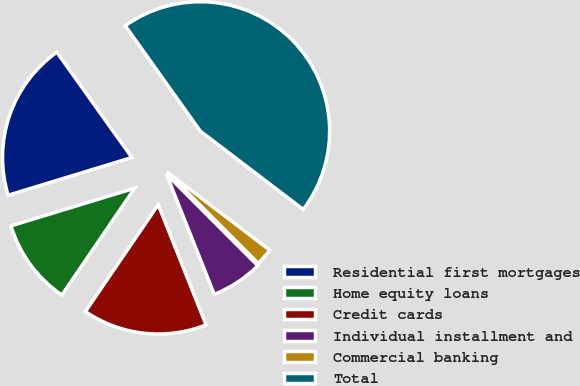<chart> <loc_0><loc_0><loc_500><loc_500><pie_chart><fcel>Residential first mortgages<fcel>Home equity loans<fcel>Credit cards<fcel>Individual installment and<fcel>Commercial banking<fcel>Total<nl><fcel>19.86%<fcel>10.77%<fcel>15.55%<fcel>6.46%<fcel>2.16%<fcel>45.21%<nl></chart> 